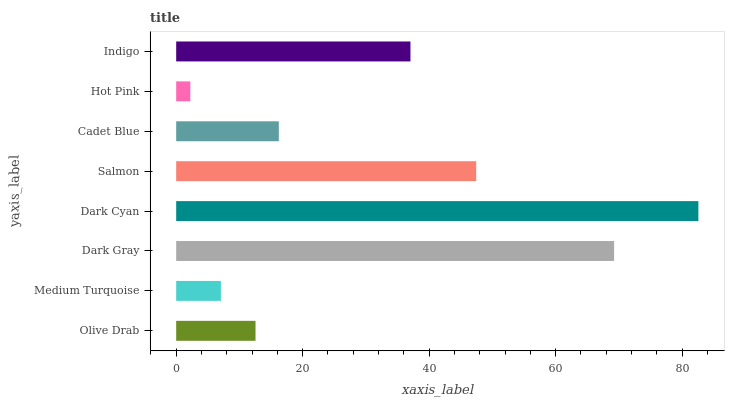Is Hot Pink the minimum?
Answer yes or no. Yes. Is Dark Cyan the maximum?
Answer yes or no. Yes. Is Medium Turquoise the minimum?
Answer yes or no. No. Is Medium Turquoise the maximum?
Answer yes or no. No. Is Olive Drab greater than Medium Turquoise?
Answer yes or no. Yes. Is Medium Turquoise less than Olive Drab?
Answer yes or no. Yes. Is Medium Turquoise greater than Olive Drab?
Answer yes or no. No. Is Olive Drab less than Medium Turquoise?
Answer yes or no. No. Is Indigo the high median?
Answer yes or no. Yes. Is Cadet Blue the low median?
Answer yes or no. Yes. Is Medium Turquoise the high median?
Answer yes or no. No. Is Dark Gray the low median?
Answer yes or no. No. 